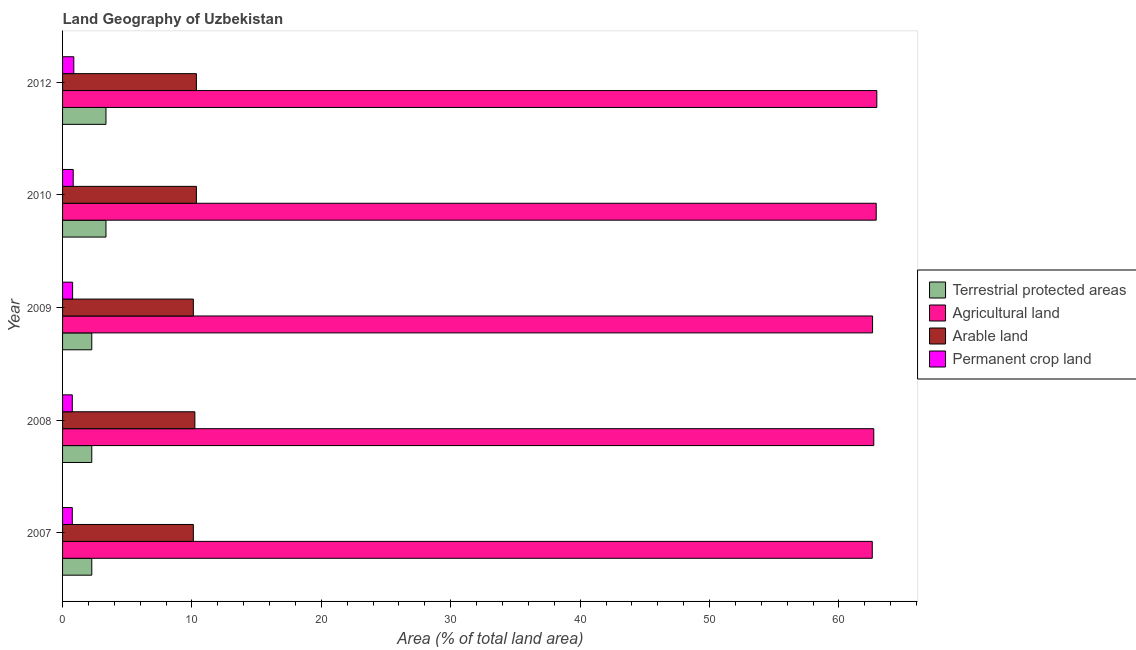How many different coloured bars are there?
Your answer should be compact. 4. How many bars are there on the 1st tick from the top?
Ensure brevity in your answer.  4. What is the label of the 1st group of bars from the top?
Your answer should be very brief. 2012. In how many cases, is the number of bars for a given year not equal to the number of legend labels?
Offer a terse response. 0. What is the percentage of area under permanent crop land in 2007?
Offer a very short reply. 0.75. Across all years, what is the maximum percentage of area under arable land?
Ensure brevity in your answer.  10.34. Across all years, what is the minimum percentage of land under terrestrial protection?
Offer a terse response. 2.26. In which year was the percentage of area under arable land maximum?
Your answer should be compact. 2010. What is the total percentage of area under permanent crop land in the graph?
Give a very brief answer. 3.97. What is the difference between the percentage of area under agricultural land in 2009 and that in 2010?
Offer a very short reply. -0.28. What is the difference between the percentage of area under permanent crop land in 2009 and the percentage of area under agricultural land in 2012?
Ensure brevity in your answer.  -62.15. What is the average percentage of area under permanent crop land per year?
Your answer should be very brief. 0.8. In the year 2012, what is the difference between the percentage of area under agricultural land and percentage of land under terrestrial protection?
Your answer should be compact. 59.57. In how many years, is the percentage of area under agricultural land greater than 6 %?
Your answer should be very brief. 5. What is the ratio of the percentage of land under terrestrial protection in 2009 to that in 2012?
Your answer should be compact. 0.67. What is the difference between the highest and the second highest percentage of area under agricultural land?
Provide a short and direct response. 0.05. What is the difference between the highest and the lowest percentage of area under arable land?
Offer a terse response. 0.24. In how many years, is the percentage of area under arable land greater than the average percentage of area under arable land taken over all years?
Make the answer very short. 3. What does the 1st bar from the top in 2007 represents?
Keep it short and to the point. Permanent crop land. What does the 2nd bar from the bottom in 2007 represents?
Provide a short and direct response. Agricultural land. Is it the case that in every year, the sum of the percentage of land under terrestrial protection and percentage of area under agricultural land is greater than the percentage of area under arable land?
Keep it short and to the point. Yes. How many bars are there?
Ensure brevity in your answer.  20. Are all the bars in the graph horizontal?
Make the answer very short. Yes. What is the difference between two consecutive major ticks on the X-axis?
Your response must be concise. 10. Does the graph contain grids?
Your answer should be very brief. No. How are the legend labels stacked?
Provide a short and direct response. Vertical. What is the title of the graph?
Provide a succinct answer. Land Geography of Uzbekistan. Does "Portugal" appear as one of the legend labels in the graph?
Offer a terse response. No. What is the label or title of the X-axis?
Your answer should be compact. Area (% of total land area). What is the Area (% of total land area) in Terrestrial protected areas in 2007?
Keep it short and to the point. 2.26. What is the Area (% of total land area) in Agricultural land in 2007?
Make the answer very short. 62.58. What is the Area (% of total land area) of Arable land in 2007?
Keep it short and to the point. 10.11. What is the Area (% of total land area) of Permanent crop land in 2007?
Your response must be concise. 0.75. What is the Area (% of total land area) in Terrestrial protected areas in 2008?
Keep it short and to the point. 2.26. What is the Area (% of total land area) in Agricultural land in 2008?
Provide a succinct answer. 62.69. What is the Area (% of total land area) of Arable land in 2008?
Provide a short and direct response. 10.23. What is the Area (% of total land area) of Permanent crop land in 2008?
Make the answer very short. 0.75. What is the Area (% of total land area) in Terrestrial protected areas in 2009?
Your response must be concise. 2.26. What is the Area (% of total land area) of Agricultural land in 2009?
Your response must be concise. 62.6. What is the Area (% of total land area) in Arable land in 2009?
Keep it short and to the point. 10.11. What is the Area (% of total land area) in Permanent crop land in 2009?
Your answer should be compact. 0.78. What is the Area (% of total land area) of Terrestrial protected areas in 2010?
Ensure brevity in your answer.  3.35. What is the Area (% of total land area) of Agricultural land in 2010?
Your answer should be very brief. 62.88. What is the Area (% of total land area) in Arable land in 2010?
Offer a very short reply. 10.34. What is the Area (% of total land area) of Permanent crop land in 2010?
Ensure brevity in your answer.  0.82. What is the Area (% of total land area) of Terrestrial protected areas in 2012?
Your answer should be very brief. 3.35. What is the Area (% of total land area) in Agricultural land in 2012?
Keep it short and to the point. 62.93. What is the Area (% of total land area) in Arable land in 2012?
Your answer should be very brief. 10.34. What is the Area (% of total land area) of Permanent crop land in 2012?
Your answer should be very brief. 0.87. Across all years, what is the maximum Area (% of total land area) of Terrestrial protected areas?
Your response must be concise. 3.35. Across all years, what is the maximum Area (% of total land area) of Agricultural land?
Your response must be concise. 62.93. Across all years, what is the maximum Area (% of total land area) of Arable land?
Ensure brevity in your answer.  10.34. Across all years, what is the maximum Area (% of total land area) of Permanent crop land?
Offer a very short reply. 0.87. Across all years, what is the minimum Area (% of total land area) in Terrestrial protected areas?
Your answer should be very brief. 2.26. Across all years, what is the minimum Area (% of total land area) of Agricultural land?
Offer a very short reply. 62.58. Across all years, what is the minimum Area (% of total land area) in Arable land?
Offer a terse response. 10.11. Across all years, what is the minimum Area (% of total land area) of Permanent crop land?
Provide a succinct answer. 0.75. What is the total Area (% of total land area) of Terrestrial protected areas in the graph?
Make the answer very short. 13.48. What is the total Area (% of total land area) in Agricultural land in the graph?
Your response must be concise. 313.68. What is the total Area (% of total land area) in Arable land in the graph?
Your response must be concise. 51.13. What is the total Area (% of total land area) in Permanent crop land in the graph?
Provide a short and direct response. 3.97. What is the difference between the Area (% of total land area) in Agricultural land in 2007 and that in 2008?
Your response must be concise. -0.12. What is the difference between the Area (% of total land area) in Arable land in 2007 and that in 2008?
Give a very brief answer. -0.12. What is the difference between the Area (% of total land area) of Permanent crop land in 2007 and that in 2008?
Your answer should be compact. 0. What is the difference between the Area (% of total land area) in Agricultural land in 2007 and that in 2009?
Provide a short and direct response. -0.02. What is the difference between the Area (% of total land area) in Permanent crop land in 2007 and that in 2009?
Provide a short and direct response. -0.02. What is the difference between the Area (% of total land area) in Terrestrial protected areas in 2007 and that in 2010?
Your answer should be compact. -1.1. What is the difference between the Area (% of total land area) of Agricultural land in 2007 and that in 2010?
Your answer should be compact. -0.31. What is the difference between the Area (% of total land area) in Arable land in 2007 and that in 2010?
Your answer should be very brief. -0.24. What is the difference between the Area (% of total land area) of Permanent crop land in 2007 and that in 2010?
Your response must be concise. -0.07. What is the difference between the Area (% of total land area) of Terrestrial protected areas in 2007 and that in 2012?
Provide a succinct answer. -1.1. What is the difference between the Area (% of total land area) in Agricultural land in 2007 and that in 2012?
Provide a short and direct response. -0.35. What is the difference between the Area (% of total land area) of Arable land in 2007 and that in 2012?
Your answer should be compact. -0.24. What is the difference between the Area (% of total land area) in Permanent crop land in 2007 and that in 2012?
Offer a terse response. -0.12. What is the difference between the Area (% of total land area) of Terrestrial protected areas in 2008 and that in 2009?
Provide a succinct answer. 0. What is the difference between the Area (% of total land area) of Agricultural land in 2008 and that in 2009?
Offer a very short reply. 0.09. What is the difference between the Area (% of total land area) of Arable land in 2008 and that in 2009?
Give a very brief answer. 0.12. What is the difference between the Area (% of total land area) in Permanent crop land in 2008 and that in 2009?
Give a very brief answer. -0.02. What is the difference between the Area (% of total land area) in Terrestrial protected areas in 2008 and that in 2010?
Your response must be concise. -1.1. What is the difference between the Area (% of total land area) of Agricultural land in 2008 and that in 2010?
Make the answer very short. -0.19. What is the difference between the Area (% of total land area) in Arable land in 2008 and that in 2010?
Keep it short and to the point. -0.12. What is the difference between the Area (% of total land area) in Permanent crop land in 2008 and that in 2010?
Your answer should be very brief. -0.07. What is the difference between the Area (% of total land area) in Terrestrial protected areas in 2008 and that in 2012?
Give a very brief answer. -1.1. What is the difference between the Area (% of total land area) of Agricultural land in 2008 and that in 2012?
Your answer should be compact. -0.24. What is the difference between the Area (% of total land area) in Arable land in 2008 and that in 2012?
Make the answer very short. -0.12. What is the difference between the Area (% of total land area) of Permanent crop land in 2008 and that in 2012?
Your answer should be very brief. -0.12. What is the difference between the Area (% of total land area) of Terrestrial protected areas in 2009 and that in 2010?
Your answer should be compact. -1.1. What is the difference between the Area (% of total land area) of Agricultural land in 2009 and that in 2010?
Ensure brevity in your answer.  -0.28. What is the difference between the Area (% of total land area) of Arable land in 2009 and that in 2010?
Ensure brevity in your answer.  -0.24. What is the difference between the Area (% of total land area) of Permanent crop land in 2009 and that in 2010?
Provide a short and direct response. -0.05. What is the difference between the Area (% of total land area) in Terrestrial protected areas in 2009 and that in 2012?
Your answer should be compact. -1.1. What is the difference between the Area (% of total land area) of Agricultural land in 2009 and that in 2012?
Your answer should be compact. -0.33. What is the difference between the Area (% of total land area) of Arable land in 2009 and that in 2012?
Ensure brevity in your answer.  -0.24. What is the difference between the Area (% of total land area) of Permanent crop land in 2009 and that in 2012?
Your response must be concise. -0.09. What is the difference between the Area (% of total land area) in Terrestrial protected areas in 2010 and that in 2012?
Your answer should be compact. 0. What is the difference between the Area (% of total land area) of Agricultural land in 2010 and that in 2012?
Keep it short and to the point. -0.05. What is the difference between the Area (% of total land area) in Permanent crop land in 2010 and that in 2012?
Keep it short and to the point. -0.05. What is the difference between the Area (% of total land area) of Terrestrial protected areas in 2007 and the Area (% of total land area) of Agricultural land in 2008?
Offer a very short reply. -60.44. What is the difference between the Area (% of total land area) of Terrestrial protected areas in 2007 and the Area (% of total land area) of Arable land in 2008?
Make the answer very short. -7.97. What is the difference between the Area (% of total land area) of Terrestrial protected areas in 2007 and the Area (% of total land area) of Permanent crop land in 2008?
Provide a succinct answer. 1.51. What is the difference between the Area (% of total land area) of Agricultural land in 2007 and the Area (% of total land area) of Arable land in 2008?
Ensure brevity in your answer.  52.35. What is the difference between the Area (% of total land area) in Agricultural land in 2007 and the Area (% of total land area) in Permanent crop land in 2008?
Your response must be concise. 61.82. What is the difference between the Area (% of total land area) of Arable land in 2007 and the Area (% of total land area) of Permanent crop land in 2008?
Keep it short and to the point. 9.36. What is the difference between the Area (% of total land area) in Terrestrial protected areas in 2007 and the Area (% of total land area) in Agricultural land in 2009?
Your answer should be compact. -60.34. What is the difference between the Area (% of total land area) of Terrestrial protected areas in 2007 and the Area (% of total land area) of Arable land in 2009?
Keep it short and to the point. -7.85. What is the difference between the Area (% of total land area) in Terrestrial protected areas in 2007 and the Area (% of total land area) in Permanent crop land in 2009?
Make the answer very short. 1.48. What is the difference between the Area (% of total land area) of Agricultural land in 2007 and the Area (% of total land area) of Arable land in 2009?
Your response must be concise. 52.47. What is the difference between the Area (% of total land area) of Agricultural land in 2007 and the Area (% of total land area) of Permanent crop land in 2009?
Offer a very short reply. 61.8. What is the difference between the Area (% of total land area) in Arable land in 2007 and the Area (% of total land area) in Permanent crop land in 2009?
Ensure brevity in your answer.  9.33. What is the difference between the Area (% of total land area) in Terrestrial protected areas in 2007 and the Area (% of total land area) in Agricultural land in 2010?
Your answer should be compact. -60.62. What is the difference between the Area (% of total land area) in Terrestrial protected areas in 2007 and the Area (% of total land area) in Arable land in 2010?
Ensure brevity in your answer.  -8.09. What is the difference between the Area (% of total land area) of Terrestrial protected areas in 2007 and the Area (% of total land area) of Permanent crop land in 2010?
Provide a short and direct response. 1.44. What is the difference between the Area (% of total land area) in Agricultural land in 2007 and the Area (% of total land area) in Arable land in 2010?
Provide a short and direct response. 52.23. What is the difference between the Area (% of total land area) of Agricultural land in 2007 and the Area (% of total land area) of Permanent crop land in 2010?
Your response must be concise. 61.75. What is the difference between the Area (% of total land area) in Arable land in 2007 and the Area (% of total land area) in Permanent crop land in 2010?
Provide a succinct answer. 9.29. What is the difference between the Area (% of total land area) in Terrestrial protected areas in 2007 and the Area (% of total land area) in Agricultural land in 2012?
Offer a very short reply. -60.67. What is the difference between the Area (% of total land area) in Terrestrial protected areas in 2007 and the Area (% of total land area) in Arable land in 2012?
Your response must be concise. -8.09. What is the difference between the Area (% of total land area) in Terrestrial protected areas in 2007 and the Area (% of total land area) in Permanent crop land in 2012?
Your answer should be very brief. 1.39. What is the difference between the Area (% of total land area) in Agricultural land in 2007 and the Area (% of total land area) in Arable land in 2012?
Give a very brief answer. 52.23. What is the difference between the Area (% of total land area) in Agricultural land in 2007 and the Area (% of total land area) in Permanent crop land in 2012?
Offer a very short reply. 61.71. What is the difference between the Area (% of total land area) of Arable land in 2007 and the Area (% of total land area) of Permanent crop land in 2012?
Ensure brevity in your answer.  9.24. What is the difference between the Area (% of total land area) in Terrestrial protected areas in 2008 and the Area (% of total land area) in Agricultural land in 2009?
Provide a short and direct response. -60.34. What is the difference between the Area (% of total land area) of Terrestrial protected areas in 2008 and the Area (% of total land area) of Arable land in 2009?
Make the answer very short. -7.85. What is the difference between the Area (% of total land area) in Terrestrial protected areas in 2008 and the Area (% of total land area) in Permanent crop land in 2009?
Ensure brevity in your answer.  1.48. What is the difference between the Area (% of total land area) of Agricultural land in 2008 and the Area (% of total land area) of Arable land in 2009?
Your answer should be very brief. 52.59. What is the difference between the Area (% of total land area) of Agricultural land in 2008 and the Area (% of total land area) of Permanent crop land in 2009?
Provide a succinct answer. 61.92. What is the difference between the Area (% of total land area) of Arable land in 2008 and the Area (% of total land area) of Permanent crop land in 2009?
Your response must be concise. 9.45. What is the difference between the Area (% of total land area) of Terrestrial protected areas in 2008 and the Area (% of total land area) of Agricultural land in 2010?
Make the answer very short. -60.62. What is the difference between the Area (% of total land area) of Terrestrial protected areas in 2008 and the Area (% of total land area) of Arable land in 2010?
Offer a very short reply. -8.09. What is the difference between the Area (% of total land area) in Terrestrial protected areas in 2008 and the Area (% of total land area) in Permanent crop land in 2010?
Keep it short and to the point. 1.44. What is the difference between the Area (% of total land area) of Agricultural land in 2008 and the Area (% of total land area) of Arable land in 2010?
Give a very brief answer. 52.35. What is the difference between the Area (% of total land area) of Agricultural land in 2008 and the Area (% of total land area) of Permanent crop land in 2010?
Make the answer very short. 61.87. What is the difference between the Area (% of total land area) of Arable land in 2008 and the Area (% of total land area) of Permanent crop land in 2010?
Your response must be concise. 9.4. What is the difference between the Area (% of total land area) in Terrestrial protected areas in 2008 and the Area (% of total land area) in Agricultural land in 2012?
Offer a terse response. -60.67. What is the difference between the Area (% of total land area) in Terrestrial protected areas in 2008 and the Area (% of total land area) in Arable land in 2012?
Your answer should be very brief. -8.09. What is the difference between the Area (% of total land area) of Terrestrial protected areas in 2008 and the Area (% of total land area) of Permanent crop land in 2012?
Give a very brief answer. 1.39. What is the difference between the Area (% of total land area) of Agricultural land in 2008 and the Area (% of total land area) of Arable land in 2012?
Provide a succinct answer. 52.35. What is the difference between the Area (% of total land area) in Agricultural land in 2008 and the Area (% of total land area) in Permanent crop land in 2012?
Keep it short and to the point. 61.82. What is the difference between the Area (% of total land area) of Arable land in 2008 and the Area (% of total land area) of Permanent crop land in 2012?
Your response must be concise. 9.36. What is the difference between the Area (% of total land area) of Terrestrial protected areas in 2009 and the Area (% of total land area) of Agricultural land in 2010?
Ensure brevity in your answer.  -60.62. What is the difference between the Area (% of total land area) in Terrestrial protected areas in 2009 and the Area (% of total land area) in Arable land in 2010?
Give a very brief answer. -8.09. What is the difference between the Area (% of total land area) of Terrestrial protected areas in 2009 and the Area (% of total land area) of Permanent crop land in 2010?
Your answer should be very brief. 1.44. What is the difference between the Area (% of total land area) of Agricultural land in 2009 and the Area (% of total land area) of Arable land in 2010?
Ensure brevity in your answer.  52.26. What is the difference between the Area (% of total land area) of Agricultural land in 2009 and the Area (% of total land area) of Permanent crop land in 2010?
Your answer should be compact. 61.78. What is the difference between the Area (% of total land area) of Arable land in 2009 and the Area (% of total land area) of Permanent crop land in 2010?
Offer a terse response. 9.29. What is the difference between the Area (% of total land area) in Terrestrial protected areas in 2009 and the Area (% of total land area) in Agricultural land in 2012?
Keep it short and to the point. -60.67. What is the difference between the Area (% of total land area) in Terrestrial protected areas in 2009 and the Area (% of total land area) in Arable land in 2012?
Give a very brief answer. -8.09. What is the difference between the Area (% of total land area) of Terrestrial protected areas in 2009 and the Area (% of total land area) of Permanent crop land in 2012?
Provide a succinct answer. 1.39. What is the difference between the Area (% of total land area) in Agricultural land in 2009 and the Area (% of total land area) in Arable land in 2012?
Keep it short and to the point. 52.26. What is the difference between the Area (% of total land area) of Agricultural land in 2009 and the Area (% of total land area) of Permanent crop land in 2012?
Make the answer very short. 61.73. What is the difference between the Area (% of total land area) in Arable land in 2009 and the Area (% of total land area) in Permanent crop land in 2012?
Keep it short and to the point. 9.24. What is the difference between the Area (% of total land area) of Terrestrial protected areas in 2010 and the Area (% of total land area) of Agricultural land in 2012?
Offer a terse response. -59.57. What is the difference between the Area (% of total land area) in Terrestrial protected areas in 2010 and the Area (% of total land area) in Arable land in 2012?
Offer a very short reply. -6.99. What is the difference between the Area (% of total land area) of Terrestrial protected areas in 2010 and the Area (% of total land area) of Permanent crop land in 2012?
Make the answer very short. 2.48. What is the difference between the Area (% of total land area) of Agricultural land in 2010 and the Area (% of total land area) of Arable land in 2012?
Your answer should be compact. 52.54. What is the difference between the Area (% of total land area) in Agricultural land in 2010 and the Area (% of total land area) in Permanent crop land in 2012?
Make the answer very short. 62.01. What is the difference between the Area (% of total land area) of Arable land in 2010 and the Area (% of total land area) of Permanent crop land in 2012?
Your response must be concise. 9.47. What is the average Area (% of total land area) in Terrestrial protected areas per year?
Offer a very short reply. 2.7. What is the average Area (% of total land area) in Agricultural land per year?
Offer a very short reply. 62.74. What is the average Area (% of total land area) of Arable land per year?
Your response must be concise. 10.23. What is the average Area (% of total land area) of Permanent crop land per year?
Offer a terse response. 0.79. In the year 2007, what is the difference between the Area (% of total land area) of Terrestrial protected areas and Area (% of total land area) of Agricultural land?
Make the answer very short. -60.32. In the year 2007, what is the difference between the Area (% of total land area) of Terrestrial protected areas and Area (% of total land area) of Arable land?
Offer a very short reply. -7.85. In the year 2007, what is the difference between the Area (% of total land area) in Terrestrial protected areas and Area (% of total land area) in Permanent crop land?
Offer a very short reply. 1.51. In the year 2007, what is the difference between the Area (% of total land area) in Agricultural land and Area (% of total land area) in Arable land?
Offer a very short reply. 52.47. In the year 2007, what is the difference between the Area (% of total land area) in Agricultural land and Area (% of total land area) in Permanent crop land?
Keep it short and to the point. 61.82. In the year 2007, what is the difference between the Area (% of total land area) of Arable land and Area (% of total land area) of Permanent crop land?
Offer a very short reply. 9.36. In the year 2008, what is the difference between the Area (% of total land area) of Terrestrial protected areas and Area (% of total land area) of Agricultural land?
Your response must be concise. -60.44. In the year 2008, what is the difference between the Area (% of total land area) of Terrestrial protected areas and Area (% of total land area) of Arable land?
Your response must be concise. -7.97. In the year 2008, what is the difference between the Area (% of total land area) of Terrestrial protected areas and Area (% of total land area) of Permanent crop land?
Provide a succinct answer. 1.51. In the year 2008, what is the difference between the Area (% of total land area) of Agricultural land and Area (% of total land area) of Arable land?
Provide a succinct answer. 52.47. In the year 2008, what is the difference between the Area (% of total land area) in Agricultural land and Area (% of total land area) in Permanent crop land?
Offer a terse response. 61.94. In the year 2008, what is the difference between the Area (% of total land area) of Arable land and Area (% of total land area) of Permanent crop land?
Ensure brevity in your answer.  9.47. In the year 2009, what is the difference between the Area (% of total land area) of Terrestrial protected areas and Area (% of total land area) of Agricultural land?
Offer a terse response. -60.34. In the year 2009, what is the difference between the Area (% of total land area) in Terrestrial protected areas and Area (% of total land area) in Arable land?
Make the answer very short. -7.85. In the year 2009, what is the difference between the Area (% of total land area) of Terrestrial protected areas and Area (% of total land area) of Permanent crop land?
Your response must be concise. 1.48. In the year 2009, what is the difference between the Area (% of total land area) of Agricultural land and Area (% of total land area) of Arable land?
Your answer should be compact. 52.49. In the year 2009, what is the difference between the Area (% of total land area) of Agricultural land and Area (% of total land area) of Permanent crop land?
Ensure brevity in your answer.  61.82. In the year 2009, what is the difference between the Area (% of total land area) in Arable land and Area (% of total land area) in Permanent crop land?
Offer a terse response. 9.33. In the year 2010, what is the difference between the Area (% of total land area) in Terrestrial protected areas and Area (% of total land area) in Agricultural land?
Offer a very short reply. -59.53. In the year 2010, what is the difference between the Area (% of total land area) of Terrestrial protected areas and Area (% of total land area) of Arable land?
Provide a succinct answer. -6.99. In the year 2010, what is the difference between the Area (% of total land area) in Terrestrial protected areas and Area (% of total land area) in Permanent crop land?
Your response must be concise. 2.53. In the year 2010, what is the difference between the Area (% of total land area) in Agricultural land and Area (% of total land area) in Arable land?
Offer a terse response. 52.54. In the year 2010, what is the difference between the Area (% of total land area) in Agricultural land and Area (% of total land area) in Permanent crop land?
Give a very brief answer. 62.06. In the year 2010, what is the difference between the Area (% of total land area) in Arable land and Area (% of total land area) in Permanent crop land?
Your answer should be compact. 9.52. In the year 2012, what is the difference between the Area (% of total land area) in Terrestrial protected areas and Area (% of total land area) in Agricultural land?
Keep it short and to the point. -59.57. In the year 2012, what is the difference between the Area (% of total land area) in Terrestrial protected areas and Area (% of total land area) in Arable land?
Your answer should be compact. -6.99. In the year 2012, what is the difference between the Area (% of total land area) in Terrestrial protected areas and Area (% of total land area) in Permanent crop land?
Offer a very short reply. 2.48. In the year 2012, what is the difference between the Area (% of total land area) of Agricultural land and Area (% of total land area) of Arable land?
Provide a succinct answer. 52.59. In the year 2012, what is the difference between the Area (% of total land area) in Agricultural land and Area (% of total land area) in Permanent crop land?
Offer a terse response. 62.06. In the year 2012, what is the difference between the Area (% of total land area) in Arable land and Area (% of total land area) in Permanent crop land?
Your answer should be compact. 9.47. What is the ratio of the Area (% of total land area) of Arable land in 2007 to that in 2008?
Offer a terse response. 0.99. What is the ratio of the Area (% of total land area) of Permanent crop land in 2007 to that in 2008?
Your answer should be very brief. 1. What is the ratio of the Area (% of total land area) of Terrestrial protected areas in 2007 to that in 2009?
Your response must be concise. 1. What is the ratio of the Area (% of total land area) in Agricultural land in 2007 to that in 2009?
Make the answer very short. 1. What is the ratio of the Area (% of total land area) in Arable land in 2007 to that in 2009?
Ensure brevity in your answer.  1. What is the ratio of the Area (% of total land area) in Permanent crop land in 2007 to that in 2009?
Provide a short and direct response. 0.97. What is the ratio of the Area (% of total land area) in Terrestrial protected areas in 2007 to that in 2010?
Your response must be concise. 0.67. What is the ratio of the Area (% of total land area) of Agricultural land in 2007 to that in 2010?
Keep it short and to the point. 1. What is the ratio of the Area (% of total land area) of Arable land in 2007 to that in 2010?
Make the answer very short. 0.98. What is the ratio of the Area (% of total land area) in Permanent crop land in 2007 to that in 2010?
Your answer should be very brief. 0.91. What is the ratio of the Area (% of total land area) in Terrestrial protected areas in 2007 to that in 2012?
Give a very brief answer. 0.67. What is the ratio of the Area (% of total land area) of Agricultural land in 2007 to that in 2012?
Your answer should be very brief. 0.99. What is the ratio of the Area (% of total land area) of Arable land in 2007 to that in 2012?
Make the answer very short. 0.98. What is the ratio of the Area (% of total land area) of Permanent crop land in 2007 to that in 2012?
Provide a short and direct response. 0.86. What is the ratio of the Area (% of total land area) of Terrestrial protected areas in 2008 to that in 2009?
Your response must be concise. 1. What is the ratio of the Area (% of total land area) of Arable land in 2008 to that in 2009?
Give a very brief answer. 1.01. What is the ratio of the Area (% of total land area) of Permanent crop land in 2008 to that in 2009?
Make the answer very short. 0.97. What is the ratio of the Area (% of total land area) of Terrestrial protected areas in 2008 to that in 2010?
Provide a succinct answer. 0.67. What is the ratio of the Area (% of total land area) in Permanent crop land in 2008 to that in 2010?
Provide a short and direct response. 0.91. What is the ratio of the Area (% of total land area) in Terrestrial protected areas in 2008 to that in 2012?
Provide a short and direct response. 0.67. What is the ratio of the Area (% of total land area) in Agricultural land in 2008 to that in 2012?
Give a very brief answer. 1. What is the ratio of the Area (% of total land area) in Permanent crop land in 2008 to that in 2012?
Make the answer very short. 0.86. What is the ratio of the Area (% of total land area) of Terrestrial protected areas in 2009 to that in 2010?
Your answer should be compact. 0.67. What is the ratio of the Area (% of total land area) in Arable land in 2009 to that in 2010?
Keep it short and to the point. 0.98. What is the ratio of the Area (% of total land area) in Permanent crop land in 2009 to that in 2010?
Ensure brevity in your answer.  0.94. What is the ratio of the Area (% of total land area) in Terrestrial protected areas in 2009 to that in 2012?
Provide a succinct answer. 0.67. What is the ratio of the Area (% of total land area) of Arable land in 2009 to that in 2012?
Your answer should be compact. 0.98. What is the ratio of the Area (% of total land area) of Permanent crop land in 2009 to that in 2012?
Keep it short and to the point. 0.89. What is the ratio of the Area (% of total land area) in Terrestrial protected areas in 2010 to that in 2012?
Keep it short and to the point. 1. What is the ratio of the Area (% of total land area) of Agricultural land in 2010 to that in 2012?
Provide a short and direct response. 1. What is the ratio of the Area (% of total land area) of Permanent crop land in 2010 to that in 2012?
Offer a terse response. 0.95. What is the difference between the highest and the second highest Area (% of total land area) of Terrestrial protected areas?
Offer a very short reply. 0. What is the difference between the highest and the second highest Area (% of total land area) in Agricultural land?
Your response must be concise. 0.05. What is the difference between the highest and the second highest Area (% of total land area) in Permanent crop land?
Offer a terse response. 0.05. What is the difference between the highest and the lowest Area (% of total land area) of Terrestrial protected areas?
Offer a very short reply. 1.1. What is the difference between the highest and the lowest Area (% of total land area) in Agricultural land?
Provide a short and direct response. 0.35. What is the difference between the highest and the lowest Area (% of total land area) of Arable land?
Your answer should be compact. 0.24. What is the difference between the highest and the lowest Area (% of total land area) in Permanent crop land?
Keep it short and to the point. 0.12. 